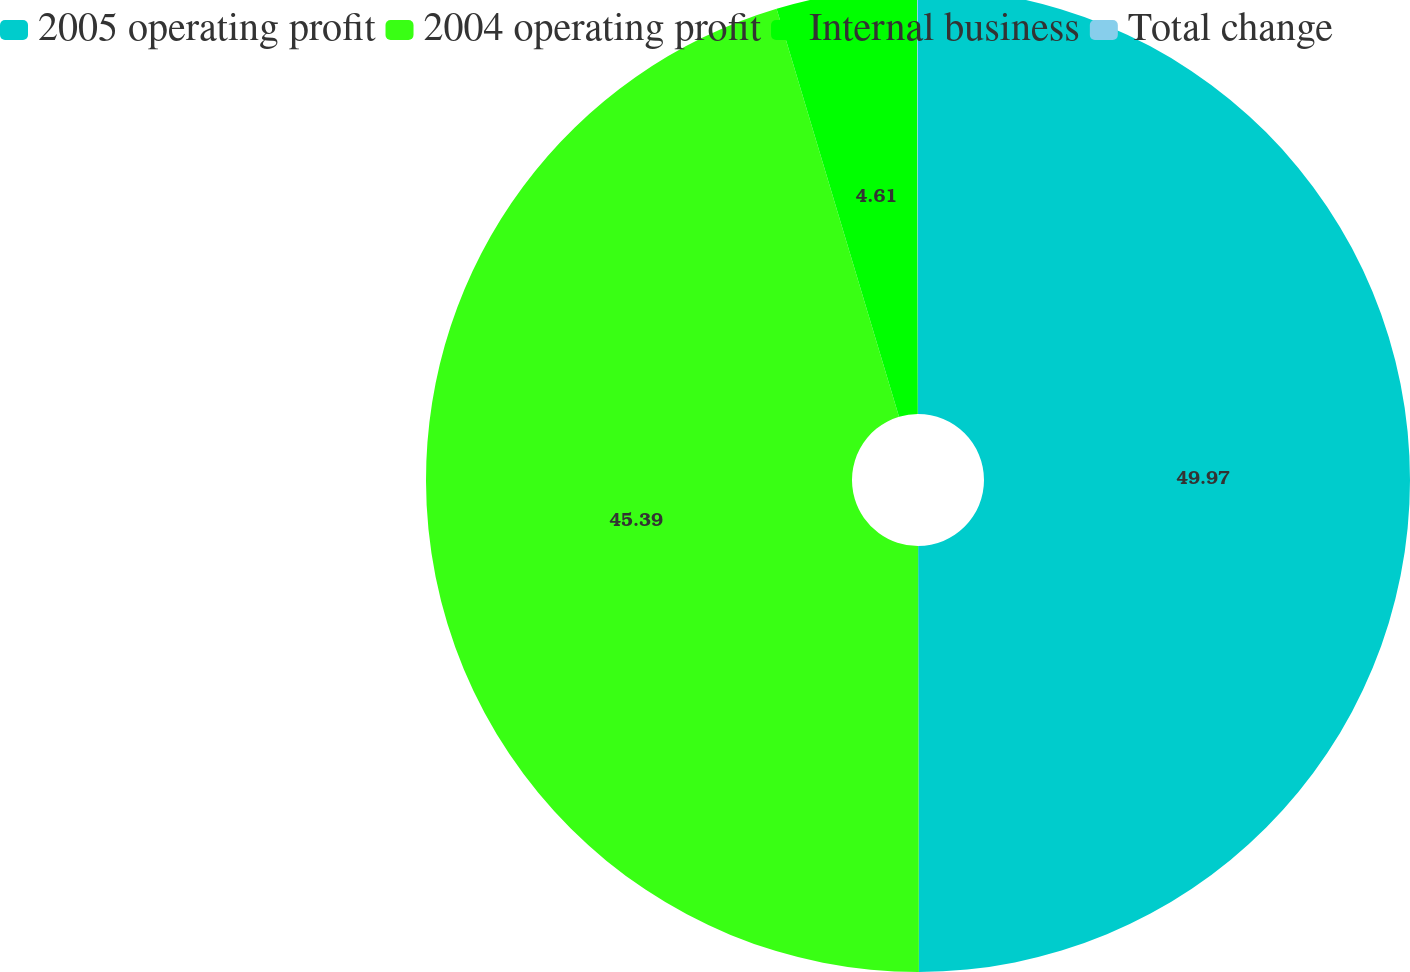Convert chart to OTSL. <chart><loc_0><loc_0><loc_500><loc_500><pie_chart><fcel>2005 operating profit<fcel>2004 operating profit<fcel>Internal business<fcel>Total change<nl><fcel>49.97%<fcel>45.39%<fcel>4.61%<fcel>0.03%<nl></chart> 